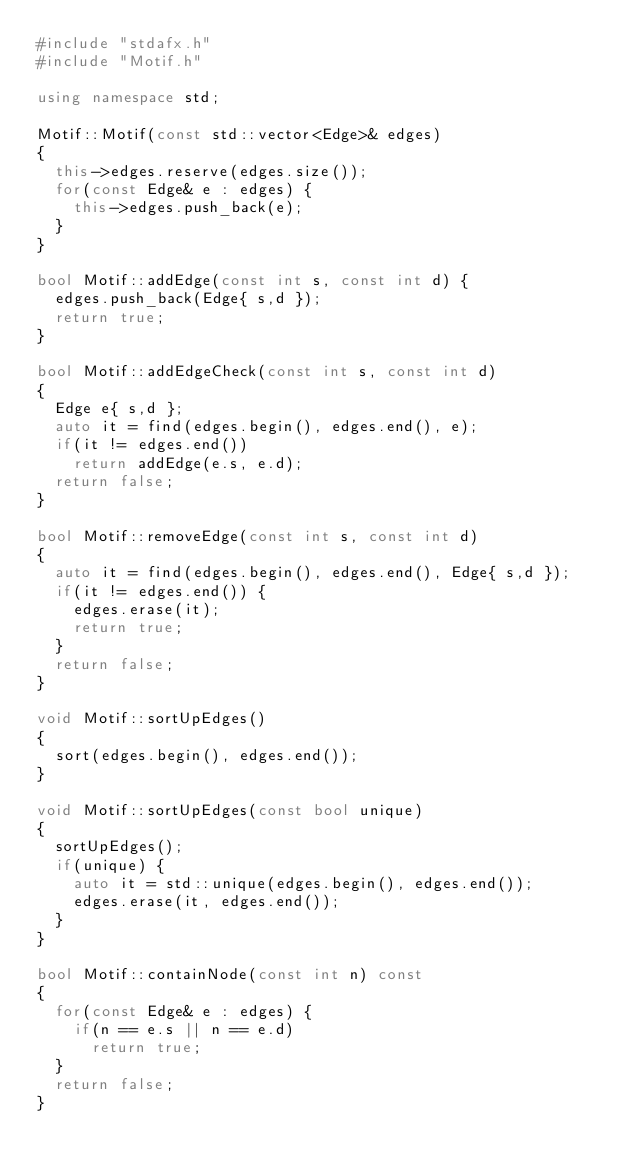<code> <loc_0><loc_0><loc_500><loc_500><_C++_>#include "stdafx.h"
#include "Motif.h"

using namespace std;

Motif::Motif(const std::vector<Edge>& edges)
{
	this->edges.reserve(edges.size());
	for(const Edge& e : edges) {
		this->edges.push_back(e);
	}
}

bool Motif::addEdge(const int s, const int d) {
	edges.push_back(Edge{ s,d });
	return true;
}

bool Motif::addEdgeCheck(const int s, const int d)
{
	Edge e{ s,d };
	auto it = find(edges.begin(), edges.end(), e);
	if(it != edges.end())
		return addEdge(e.s, e.d);
	return false;
}

bool Motif::removeEdge(const int s, const int d)
{
	auto it = find(edges.begin(), edges.end(), Edge{ s,d });
	if(it != edges.end()) {
		edges.erase(it);
		return true;
	}
	return false;
}

void Motif::sortUpEdges()
{
	sort(edges.begin(), edges.end());
}

void Motif::sortUpEdges(const bool unique)
{
	sortUpEdges();
	if(unique) {
		auto it = std::unique(edges.begin(), edges.end());
		edges.erase(it, edges.end());
	}
}

bool Motif::containNode(const int n) const
{
	for(const Edge& e : edges) {
		if(n == e.s || n == e.d)
			return true;
	}
	return false;
}
</code> 